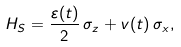<formula> <loc_0><loc_0><loc_500><loc_500>H _ { S } = \frac { \varepsilon ( t ) } { 2 } \, \sigma _ { z } + v ( t ) \, \sigma _ { x } ,</formula> 